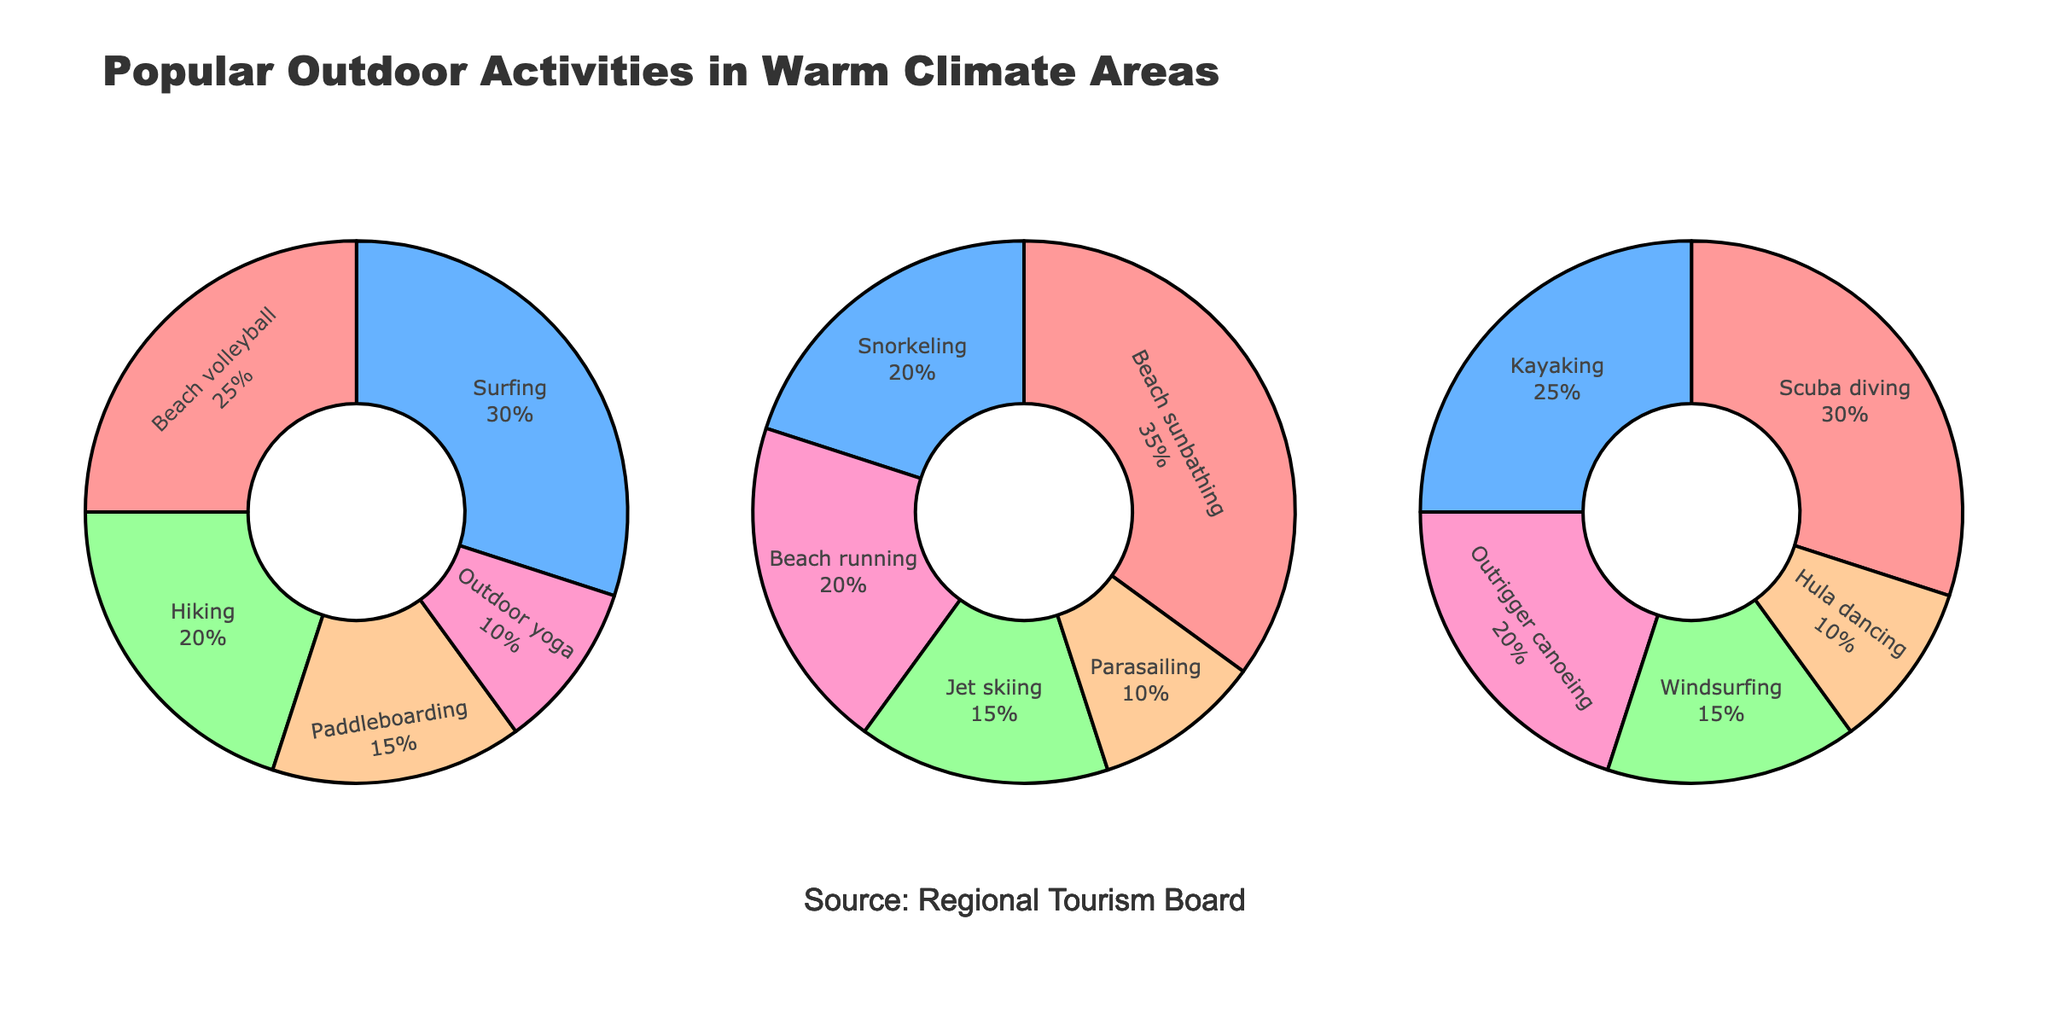What's the overall title of the figure? The overall title is the text displayed at the top center of the figure.
Answer: Popular Outdoor Activities in Warm Climate Areas Which activity has the highest percentage in California? By looking at the California pie chart, we see the activity segment with the largest portion labeled with the percentage.
Answer: Surfing What is the sum of the percentages of Hiking and Outdoor yoga in California? Add the percentages of Hiking and Outdoor yoga from the California pie chart (20% and 10%).
Answer: 30% Which region includes Hula dancing as a popular outdoor activity? Look at the pie charts for each region and identify which one includes a segment labeled Hula dancing.
Answer: Hawaii Compared to California, which activity is more popular in Florida by percentage? Compare activity percentages from the Florida and California pie charts. For instance, Beach sunbathing is 35% in Florida and does not appear in California.
Answer: Beach sunbathing What are the colors used in the pie charts? The common colors for the segments across all pie charts are listed in the provided data.
Answer: Light red, light blue, light green, light orange, light pink What percentage of activities in Hawaii is represented by Kayaking and Outrigger canoeing together? Add the percentages of Kayaking and Outrigger canoeing from the Hawaii pie chart (25% and 20%).
Answer: 45% Which region has the highest percentage for a single activity and what is it? Identify the largest percentage across all pie charts. Beach sunbathing in Florida is the largest single value at 35%.
Answer: Florida, Beach sunbathing How many activities have a percentage of 20% in any region? Count all segments labeled with 20% across the three regions. Florida (Beach running), California (Hiking), and Hawaii (Outrigger canoeing).
Answer: 3 Out of Surfing and Paddleboarding in California, which has a lower percentage, and by how much? Compare the percentages of Surfing and Paddleboarding from the California pie chart (30% and 15%) and subtract.
Answer: Paddleboarding, by 15% 